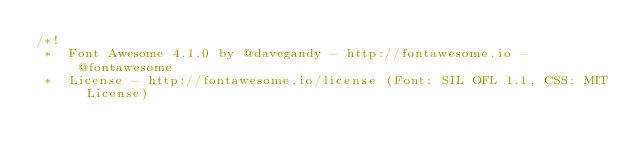<code> <loc_0><loc_0><loc_500><loc_500><_CSS_>/*!
 *  Font Awesome 4.1.0 by @davegandy - http://fontawesome.io - @fontawesome
 *  License - http://fontawesome.io/license (Font: SIL OFL 1.1, CSS: MIT License)</code> 